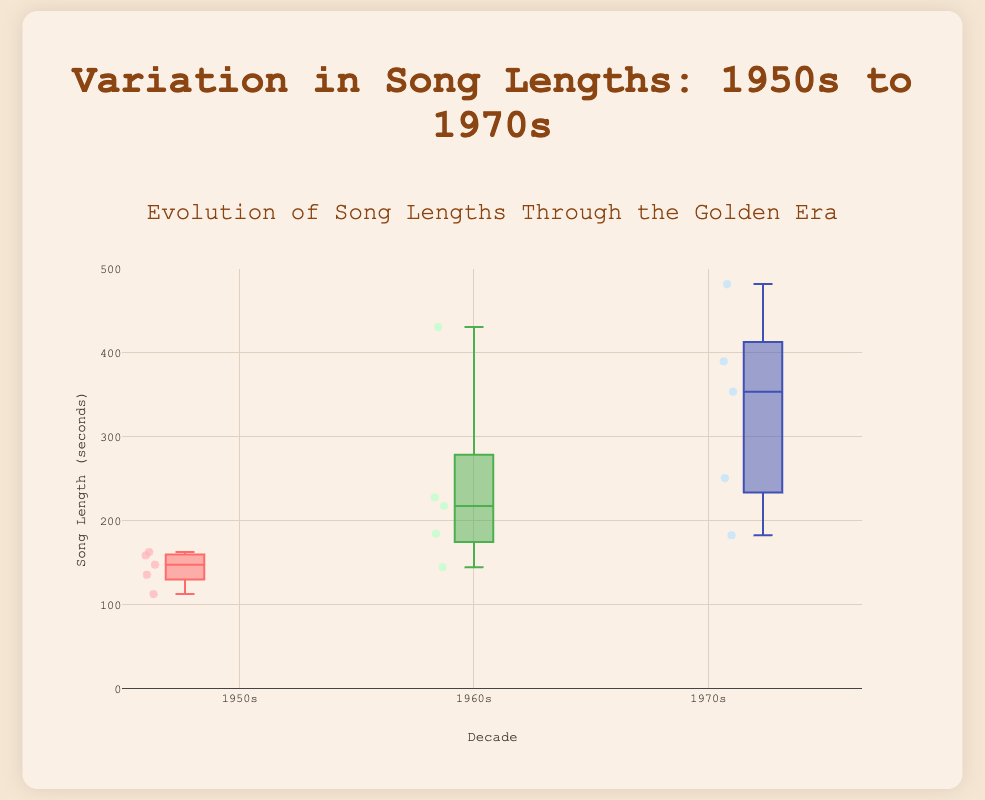What is the median song length in the 1960s? To find the median, we need to identify the middle value in the ordered list of song lengths for the 1960s. The song lengths are 431, 228, 218, 145, and 185 seconds. Ordering them gives 145, 185, 218, 228, and 431 seconds. The median is the middle value, which is 218 seconds.
Answer: 218 seconds Which decade has the longest song in the data? To determine this, we need to compare the maximum song lengths from each decade. The maximum lengths are 163 seconds for the 1950s, 431 seconds for the 1960s, and 482 seconds for the 1970s. The 1970s have the longest song length of 482 seconds.
Answer: 1970s What is the interquartile range (IQR) of song lengths in the 1950s? The IQR is the difference between the third quartile (Q3) and the first quartile (Q1). For the 1950s, the song lengths are 159, 136, 163, 113, and 148. Ordering them gives 113, 136, 148, 159, and 163. Q1 is 136, and Q3 is 159. The IQR is 159 - 136 = 23 seconds.
Answer: 23 seconds How does the median song length in the 1950s compare to the 1970s? The median song lengths of the 1950s and 1970s need to be compared. For the 1950s, the ordered song lengths are 113, 136, 148, 159, and 163, with a median of 148. For the 1970s, the ordered lengths are 183, 251, 354, 390, and 482, with a median of 354. Therefore, the 1970s have a higher median song length compared to the 1950s.
Answer: The 1970s have a higher median Which decade shows the widest range of song lengths? The range is found by subtracting the shortest song length from the longest in each decade. The ranges are 163 - 113 = 50 seconds for the 1950s, 431 - 145 = 286 seconds for the 1960s, and 482 - 183 = 299 seconds for the 1970s. The 1970s show the widest range.
Answer: 1970s What is the average song length across all decades? Sum all the song lengths and divide by the total number of songs. The lengths are 159, 136, 163, 113, 148, 431, 228, 218, 145, 185, 354, 482, 390, 183, and 251 seconds. The total is 4286 seconds across 15 songs. The average length is 4286 / 15 = approximately 286 seconds.
Answer: 286 seconds Which decade has the most consistent (least variable) song lengths? The consistency of song lengths is assessed by the range and IQR for each decade. Smaller ranges and IQRs indicate more consistency. The ranges are 50 seconds for the 1950s, 286 seconds for the 1960s, and 299 seconds for the 1970s. The IQRs are 23 seconds for the 1950s, approximately 83 seconds (228 - 145) for the 1960s, and 139 seconds (390 - 251) for the 1970s. The 1950s show the least variability.
Answer: 1950s 